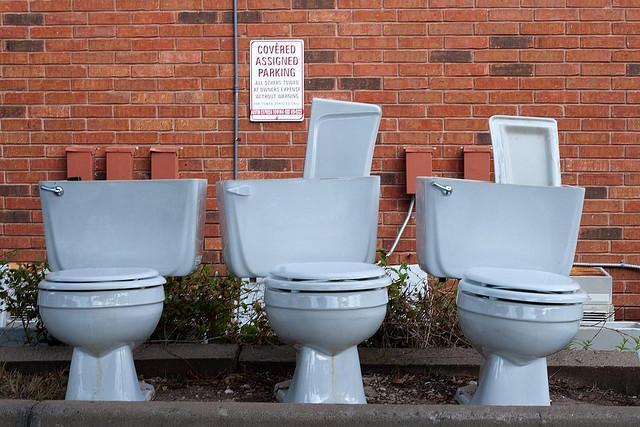How many toilets are there?
Give a very brief answer. 3. 